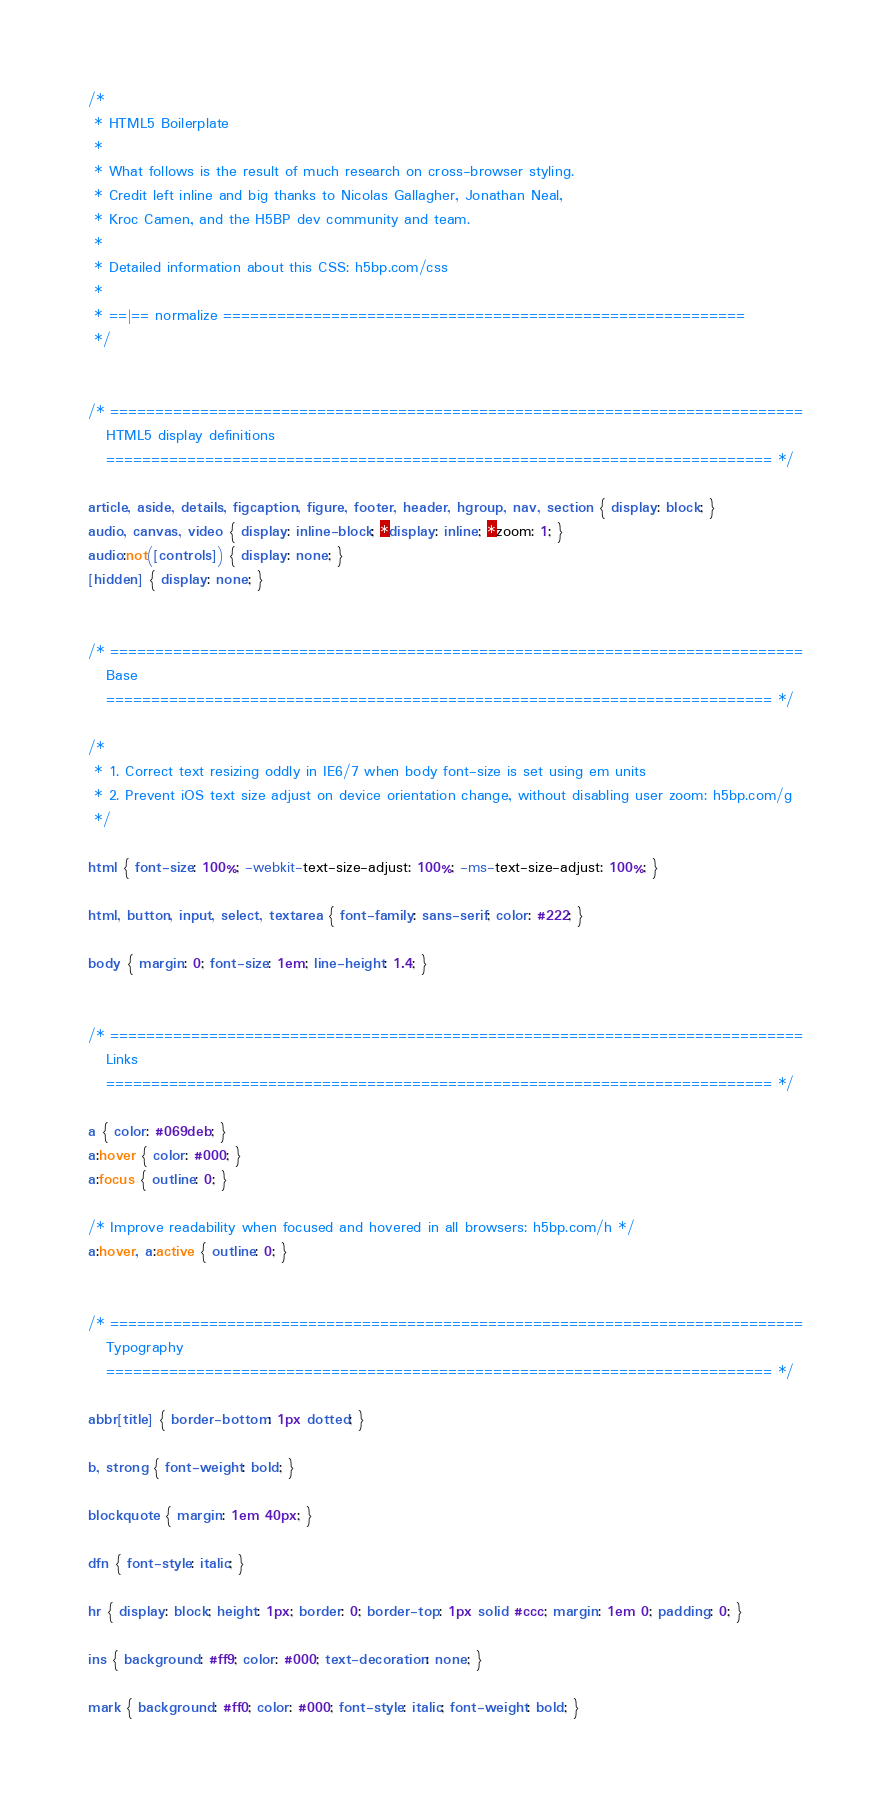Convert code to text. <code><loc_0><loc_0><loc_500><loc_500><_CSS_>/*
 * HTML5 Boilerplate
 *
 * What follows is the result of much research on cross-browser styling.
 * Credit left inline and big thanks to Nicolas Gallagher, Jonathan Neal,
 * Kroc Camen, and the H5BP dev community and team.
 *
 * Detailed information about this CSS: h5bp.com/css
 *
 * ==|== normalize ==========================================================
 */


/* =============================================================================
   HTML5 display definitions
   ========================================================================== */

article, aside, details, figcaption, figure, footer, header, hgroup, nav, section { display: block; }
audio, canvas, video { display: inline-block; *display: inline; *zoom: 1; }
audio:not([controls]) { display: none; }
[hidden] { display: none; }


/* =============================================================================
   Base
   ========================================================================== */

/*
 * 1. Correct text resizing oddly in IE6/7 when body font-size is set using em units
 * 2. Prevent iOS text size adjust on device orientation change, without disabling user zoom: h5bp.com/g
 */

html { font-size: 100%; -webkit-text-size-adjust: 100%; -ms-text-size-adjust: 100%; }

html, button, input, select, textarea { font-family: sans-serif; color: #222; }

body { margin: 0; font-size: 1em; line-height: 1.4; }


/* =============================================================================
   Links
   ========================================================================== */

a { color: #069deb; }
a:hover { color: #000; }
a:focus { outline: 0; }

/* Improve readability when focused and hovered in all browsers: h5bp.com/h */
a:hover, a:active { outline: 0; }


/* =============================================================================
   Typography
   ========================================================================== */

abbr[title] { border-bottom: 1px dotted; }

b, strong { font-weight: bold; }

blockquote { margin: 1em 40px; }

dfn { font-style: italic; }

hr { display: block; height: 1px; border: 0; border-top: 1px solid #ccc; margin: 1em 0; padding: 0; }

ins { background: #ff9; color: #000; text-decoration: none; }

mark { background: #ff0; color: #000; font-style: italic; font-weight: bold; }
</code> 